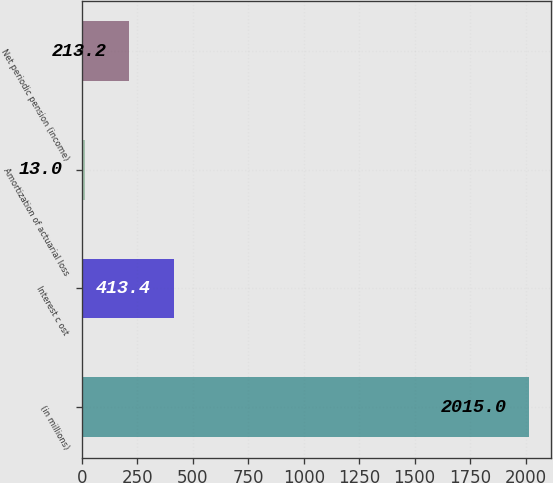Convert chart. <chart><loc_0><loc_0><loc_500><loc_500><bar_chart><fcel>(in millions)<fcel>Interest c ost<fcel>Amortization of actuarial loss<fcel>Net periodic pension (income)<nl><fcel>2015<fcel>413.4<fcel>13<fcel>213.2<nl></chart> 